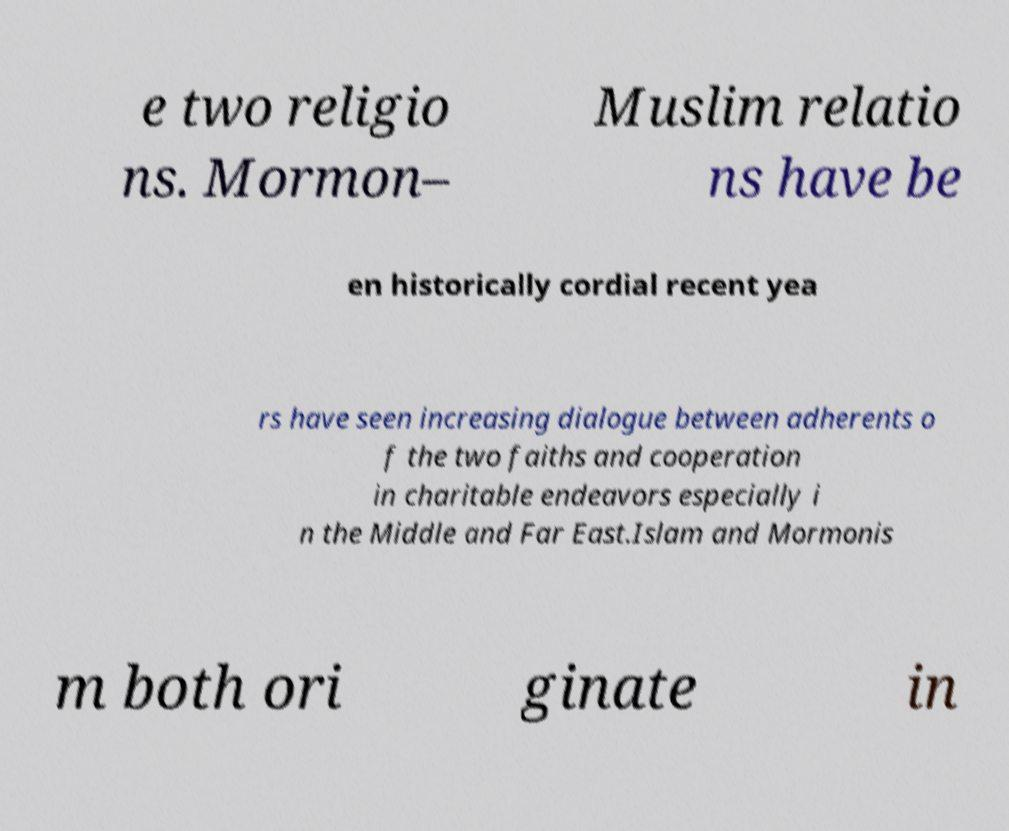Can you accurately transcribe the text from the provided image for me? e two religio ns. Mormon– Muslim relatio ns have be en historically cordial recent yea rs have seen increasing dialogue between adherents o f the two faiths and cooperation in charitable endeavors especially i n the Middle and Far East.Islam and Mormonis m both ori ginate in 